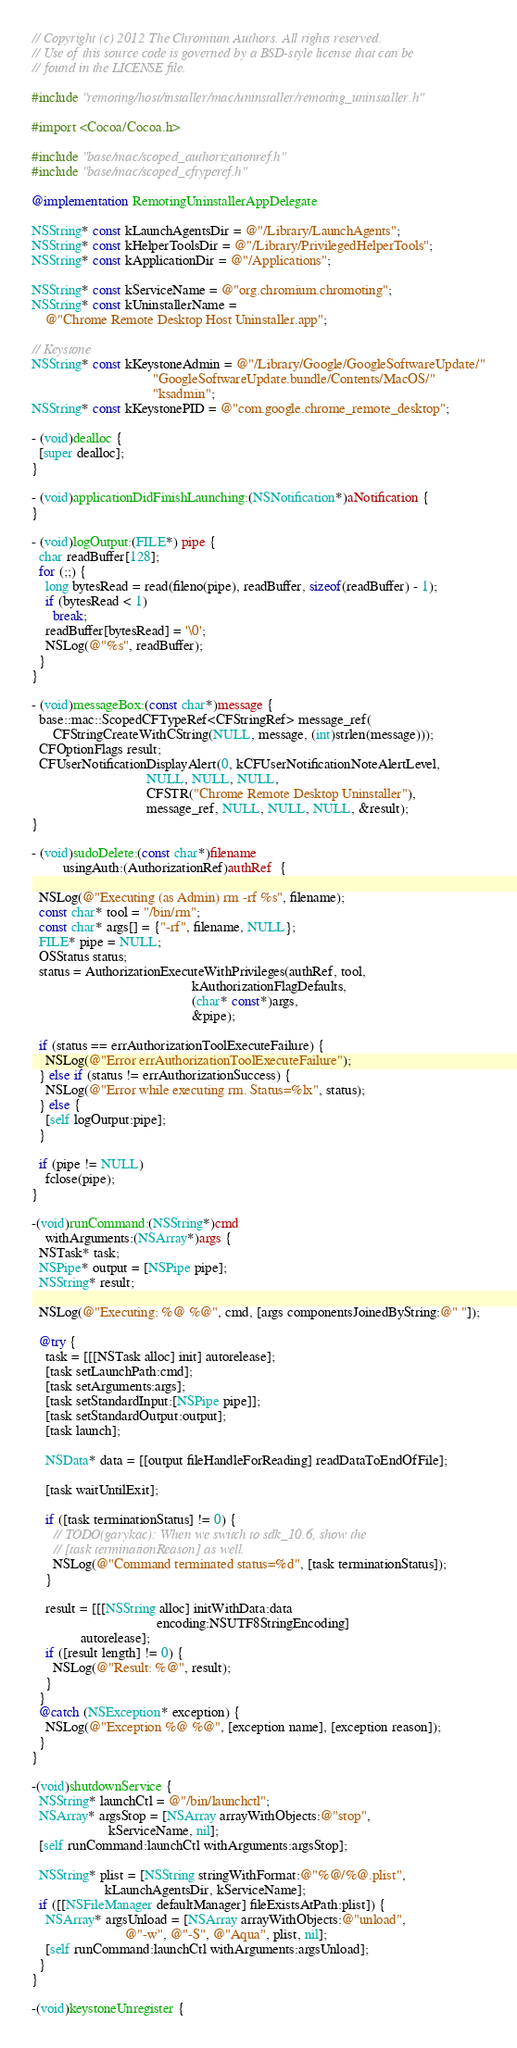<code> <loc_0><loc_0><loc_500><loc_500><_ObjectiveC_>// Copyright (c) 2012 The Chromium Authors. All rights reserved.
// Use of this source code is governed by a BSD-style license that can be
// found in the LICENSE file.

#include "remoting/host/installer/mac/uninstaller/remoting_uninstaller.h"

#import <Cocoa/Cocoa.h>

#include "base/mac/scoped_authorizationref.h"
#include "base/mac/scoped_cftyperef.h"

@implementation RemotingUninstallerAppDelegate

NSString* const kLaunchAgentsDir = @"/Library/LaunchAgents";
NSString* const kHelperToolsDir = @"/Library/PrivilegedHelperTools";
NSString* const kApplicationDir = @"/Applications";

NSString* const kServiceName = @"org.chromium.chromoting";
NSString* const kUninstallerName =
    @"Chrome Remote Desktop Host Uninstaller.app";

// Keystone
NSString* const kKeystoneAdmin = @"/Library/Google/GoogleSoftwareUpdate/"
                                   "GoogleSoftwareUpdate.bundle/Contents/MacOS/"
                                   "ksadmin";
NSString* const kKeystonePID = @"com.google.chrome_remote_desktop";

- (void)dealloc {
  [super dealloc];
}

- (void)applicationDidFinishLaunching:(NSNotification*)aNotification {
}

- (void)logOutput:(FILE*) pipe {
  char readBuffer[128];
  for (;;) {
    long bytesRead = read(fileno(pipe), readBuffer, sizeof(readBuffer) - 1);
    if (bytesRead < 1)
      break;
    readBuffer[bytesRead] = '\0';
    NSLog(@"%s", readBuffer);
  }
}

- (void)messageBox:(const char*)message {
  base::mac::ScopedCFTypeRef<CFStringRef> message_ref(
      CFStringCreateWithCString(NULL, message, (int)strlen(message)));
  CFOptionFlags result;
  CFUserNotificationDisplayAlert(0, kCFUserNotificationNoteAlertLevel,
                                 NULL, NULL, NULL,
                                 CFSTR("Chrome Remote Desktop Uninstaller"),
                                 message_ref, NULL, NULL, NULL, &result);
}

- (void)sudoDelete:(const char*)filename
         usingAuth:(AuthorizationRef)authRef  {

  NSLog(@"Executing (as Admin) rm -rf %s", filename);
  const char* tool = "/bin/rm";
  const char* args[] = {"-rf", filename, NULL};
  FILE* pipe = NULL;
  OSStatus status;
  status = AuthorizationExecuteWithPrivileges(authRef, tool,
                                              kAuthorizationFlagDefaults,
                                              (char* const*)args,
                                              &pipe);

  if (status == errAuthorizationToolExecuteFailure) {
    NSLog(@"Error errAuthorizationToolExecuteFailure");
  } else if (status != errAuthorizationSuccess) {
    NSLog(@"Error while executing rm. Status=%lx", status);
  } else {
    [self logOutput:pipe];
  }

  if (pipe != NULL)
    fclose(pipe);
}

-(void)runCommand:(NSString*)cmd
    withArguments:(NSArray*)args {
  NSTask* task;
  NSPipe* output = [NSPipe pipe];
  NSString* result;

  NSLog(@"Executing: %@ %@", cmd, [args componentsJoinedByString:@" "]);

  @try {
    task = [[[NSTask alloc] init] autorelease];
    [task setLaunchPath:cmd];
    [task setArguments:args];
    [task setStandardInput:[NSPipe pipe]];
    [task setStandardOutput:output];
    [task launch];

    NSData* data = [[output fileHandleForReading] readDataToEndOfFile];

    [task waitUntilExit];

    if ([task terminationStatus] != 0) {
      // TODO(garykac): When we switch to sdk_10.6, show the
      // [task terminationReason] as well.
      NSLog(@"Command terminated status=%d", [task terminationStatus]);
    }

    result = [[[NSString alloc] initWithData:data
                                    encoding:NSUTF8StringEncoding]
              autorelease];
    if ([result length] != 0) {
      NSLog(@"Result: %@", result);
    }
  }
  @catch (NSException* exception) {
    NSLog(@"Exception %@ %@", [exception name], [exception reason]);
  }
}

-(void)shutdownService {
  NSString* launchCtl = @"/bin/launchctl";
  NSArray* argsStop = [NSArray arrayWithObjects:@"stop",
                      kServiceName, nil];
  [self runCommand:launchCtl withArguments:argsStop];

  NSString* plist = [NSString stringWithFormat:@"%@/%@.plist",
                     kLaunchAgentsDir, kServiceName];
  if ([[NSFileManager defaultManager] fileExistsAtPath:plist]) {
    NSArray* argsUnload = [NSArray arrayWithObjects:@"unload",
                           @"-w", @"-S", @"Aqua", plist, nil];
    [self runCommand:launchCtl withArguments:argsUnload];
  }
}

-(void)keystoneUnregister {</code> 